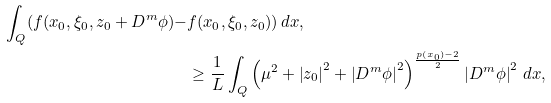Convert formula to latex. <formula><loc_0><loc_0><loc_500><loc_500>\int _ { Q } ( f ( x _ { 0 } , \xi _ { 0 } , z _ { 0 } + D ^ { m } \phi ) - & f ( x _ { 0 } , \xi _ { 0 } , z _ { 0 } ) ) \, d x , \\ & \geq \frac { 1 } { L } \int _ { Q } \left ( \mu ^ { 2 } + \left | z _ { 0 } \right | ^ { 2 } + \left | D ^ { m } \phi \right | ^ { 2 } \right ) ^ { \frac { p \left ( x _ { 0 } \right ) - 2 } { 2 } } \left | D ^ { m } \phi \right | ^ { 2 } \, d x ,</formula> 